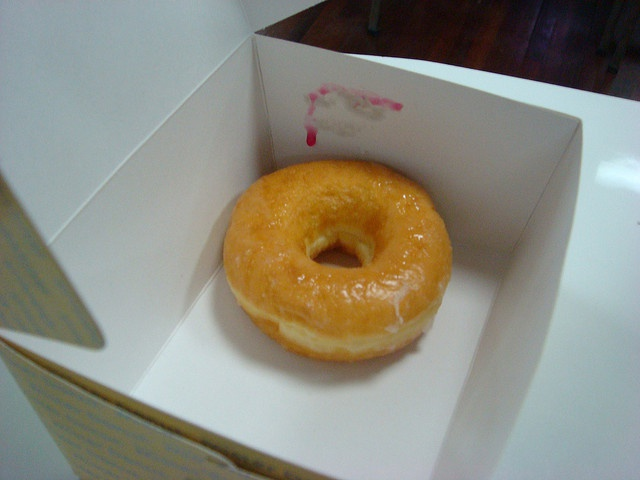Describe the objects in this image and their specific colors. I can see a donut in darkgray, olive, and tan tones in this image. 